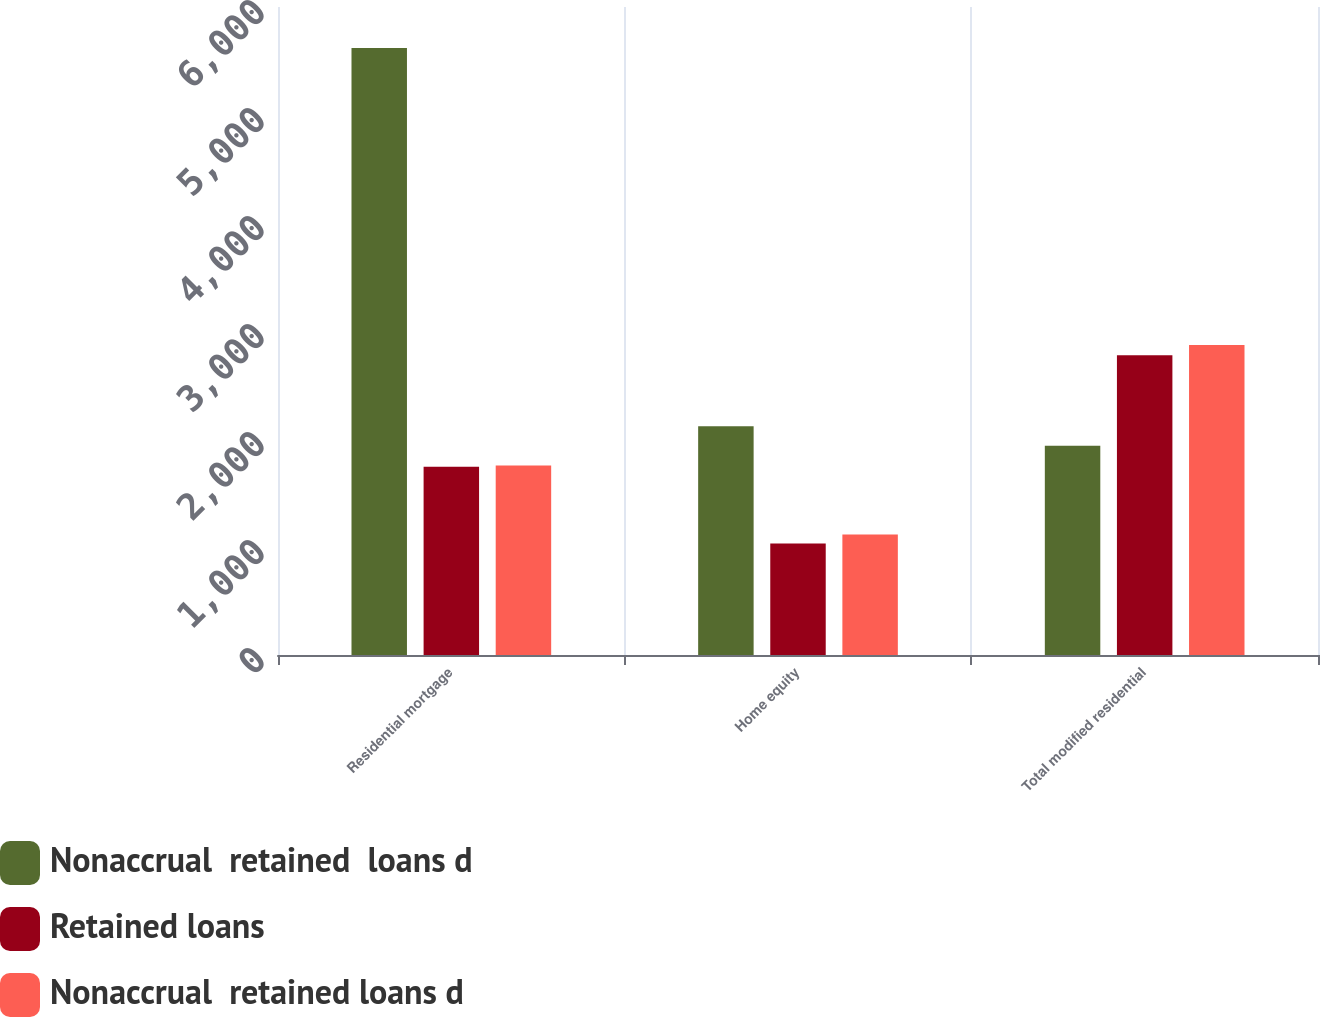Convert chart. <chart><loc_0><loc_0><loc_500><loc_500><stacked_bar_chart><ecel><fcel>Residential mortgage<fcel>Home equity<fcel>Total modified residential<nl><fcel>Nonaccrual  retained  loans d<fcel>5620<fcel>2118<fcel>1936.5<nl><fcel>Retained loans<fcel>1743<fcel>1032<fcel>2775<nl><fcel>Nonaccrual  retained loans d<fcel>1755<fcel>1116<fcel>2871<nl></chart> 